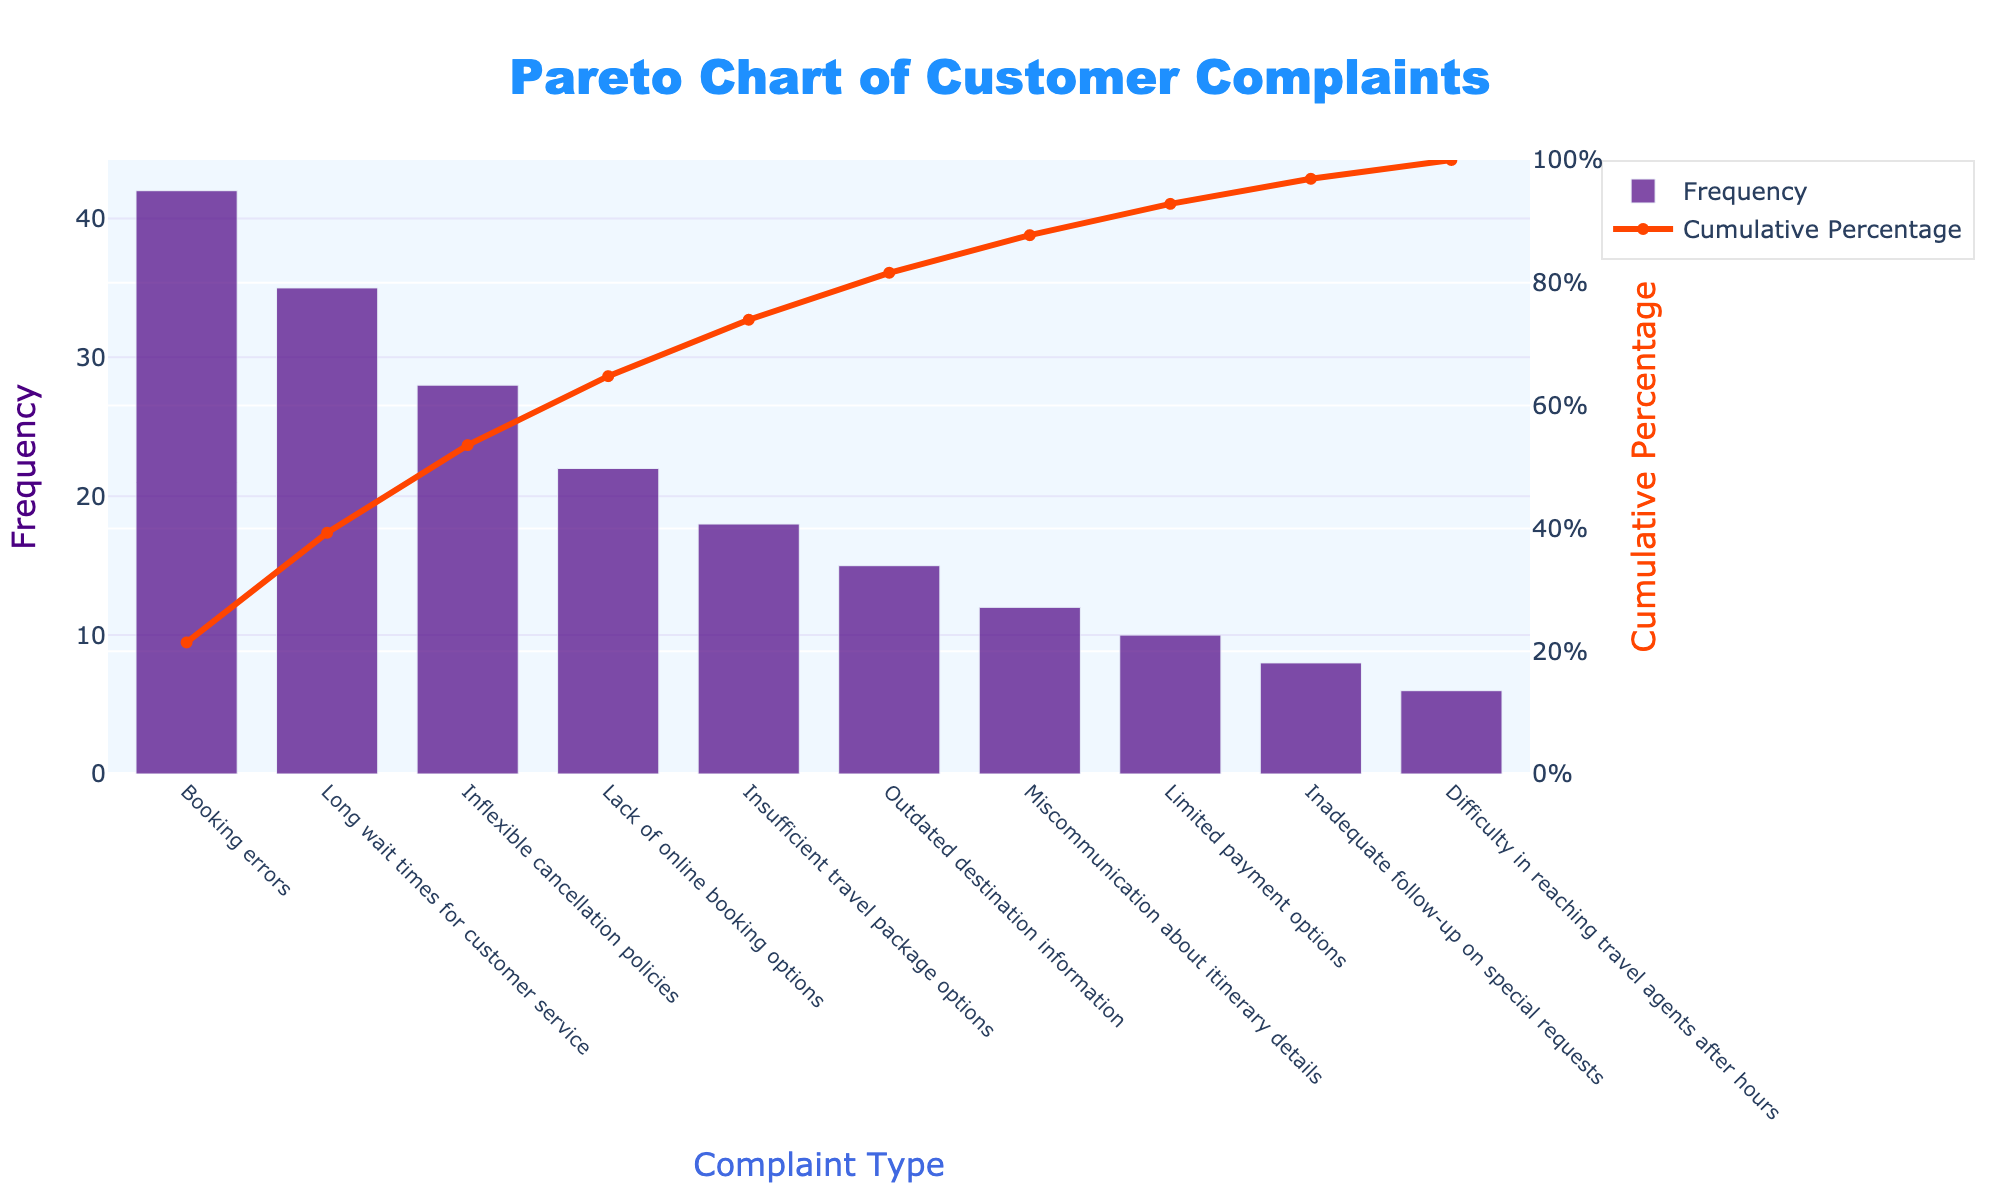How many types of customer complaints are shown in the chart? The chart lists different customer complaints on the x-axis. By counting the categories, we can determine the total number of complaint types.
Answer: 10 What does the orange line in the chart represent? The orange line represents the cumulative percentage, which shows the cumulative proportion of complaints as you move from left to right along the x-axis.
Answer: Cumulative Percentage According to the chart, which complaint type occurs most frequently? The highest bar in the chart represents the most frequent complaint type. In the figure, the tallest bar corresponds to "Booking errors."
Answer: Booking errors What percentage of total complaints is accounted for by the two most frequent complaint types? The cumulative percentage of the two most frequent complaint types is indicated by the second point on the orange line. Adding the percentages for "Booking errors" and "Long wait times for customer service" from the cumulative percentage line gives the answer.
Answer: 53.5% Which complaint type is associated with the lowest count? The shortest bar in the chart represents the least frequent complaint type. In the figure, the shortest bar corresponds to "Difficulty in reaching travel agents after hours."
Answer: Difficulty in reaching travel agents after hours Is the cumulative percentage line smooth or does it have breaks? Observing the line graph in the chart, whether the line has breaks or is continuous can be determined. In a typical Pareto chart, the cumulative percentage line is expected to be smooth without breaks.
Answer: Smooth How many customer complaints reach at least 80% of the total complaints? To find the number of complaint types that cumulatively reach at least 80% of the total, observe the point where the cumulative percentage line crosses the 80% mark. Count the number of bars up to this point.
Answer: 6 Which complaints are classified under the first half of the cumulative percentage? Identify the complaints that fall under the first 50% on the cumulative percentage line. By observing the bars that sum to 50% or less, determine these complaint types.
Answer: Booking errors, Long wait times for customer service, Inflexible cancellation policies, Lack of online booking options By how much does the frequency of "Booking errors" exceed "Long wait times for customer service"? Subtract the frequency of "Long wait times for customer service" from the frequency of "Booking errors." Using the numbers from the bars, calculate 42 - 35.
Answer: 7 What is the combined frequency of the three least common complaint types? The least common complaints are at the far right of the x-axis. Add the frequencies of the last three bars: "Limited payment options," "Inadequate follow-up on special requests," and "Difficulty in reaching travel agents after hours."
Answer: 24 